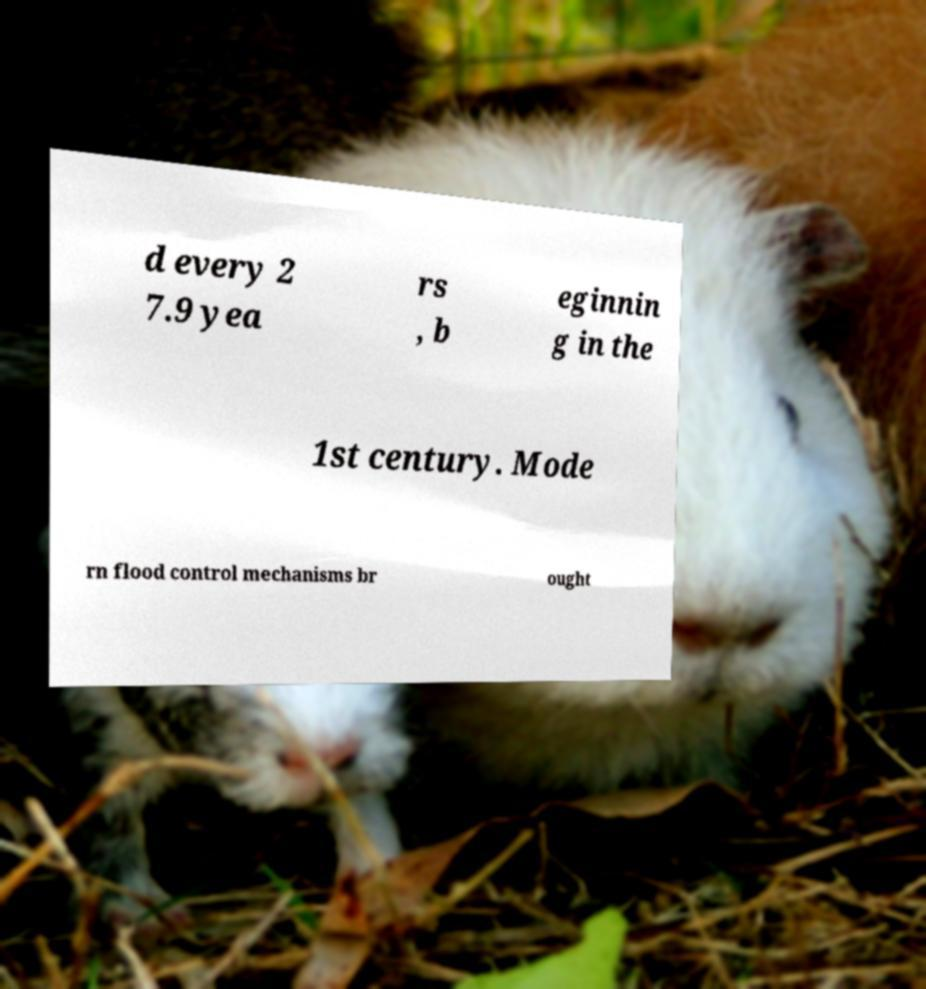I need the written content from this picture converted into text. Can you do that? d every 2 7.9 yea rs , b eginnin g in the 1st century. Mode rn flood control mechanisms br ought 